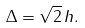Convert formula to latex. <formula><loc_0><loc_0><loc_500><loc_500>\Delta = \sqrt { 2 } \, h .</formula> 